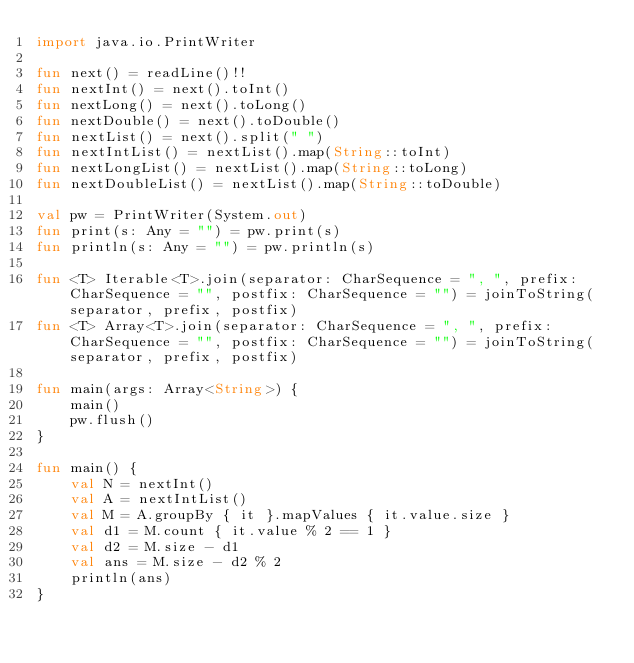<code> <loc_0><loc_0><loc_500><loc_500><_Kotlin_>import java.io.PrintWriter

fun next() = readLine()!!
fun nextInt() = next().toInt()
fun nextLong() = next().toLong()
fun nextDouble() = next().toDouble()
fun nextList() = next().split(" ")
fun nextIntList() = nextList().map(String::toInt)
fun nextLongList() = nextList().map(String::toLong)
fun nextDoubleList() = nextList().map(String::toDouble)

val pw = PrintWriter(System.out)
fun print(s: Any = "") = pw.print(s)
fun println(s: Any = "") = pw.println(s)

fun <T> Iterable<T>.join(separator: CharSequence = ", ", prefix: CharSequence = "", postfix: CharSequence = "") = joinToString(separator, prefix, postfix)
fun <T> Array<T>.join(separator: CharSequence = ", ", prefix: CharSequence = "", postfix: CharSequence = "") = joinToString(separator, prefix, postfix)

fun main(args: Array<String>) {
    main()
    pw.flush()
}

fun main() {
    val N = nextInt()
    val A = nextIntList()
    val M = A.groupBy { it }.mapValues { it.value.size }
    val d1 = M.count { it.value % 2 == 1 }
    val d2 = M.size - d1
    val ans = M.size - d2 % 2
    println(ans)
}</code> 